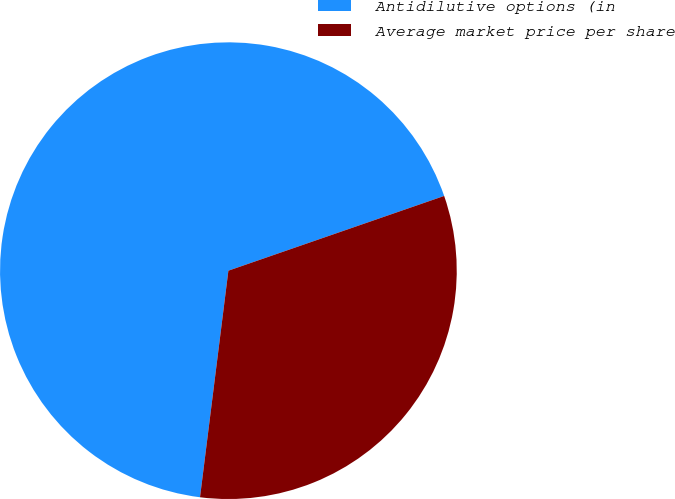<chart> <loc_0><loc_0><loc_500><loc_500><pie_chart><fcel>Antidilutive options (in<fcel>Average market price per share<nl><fcel>67.71%<fcel>32.29%<nl></chart> 